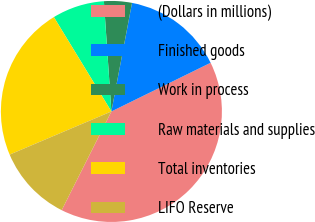Convert chart to OTSL. <chart><loc_0><loc_0><loc_500><loc_500><pie_chart><fcel>(Dollars in millions)<fcel>Finished goods<fcel>Work in process<fcel>Raw materials and supplies<fcel>Total inventories<fcel>LIFO Reserve<nl><fcel>39.68%<fcel>14.75%<fcel>4.07%<fcel>7.63%<fcel>22.67%<fcel>11.19%<nl></chart> 